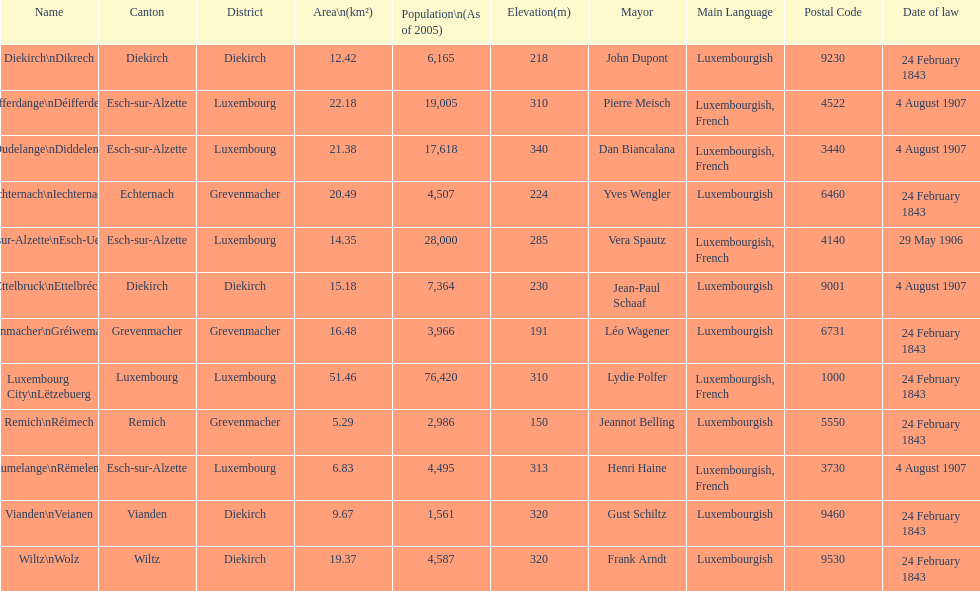What canton is the most populated? Luxembourg. 